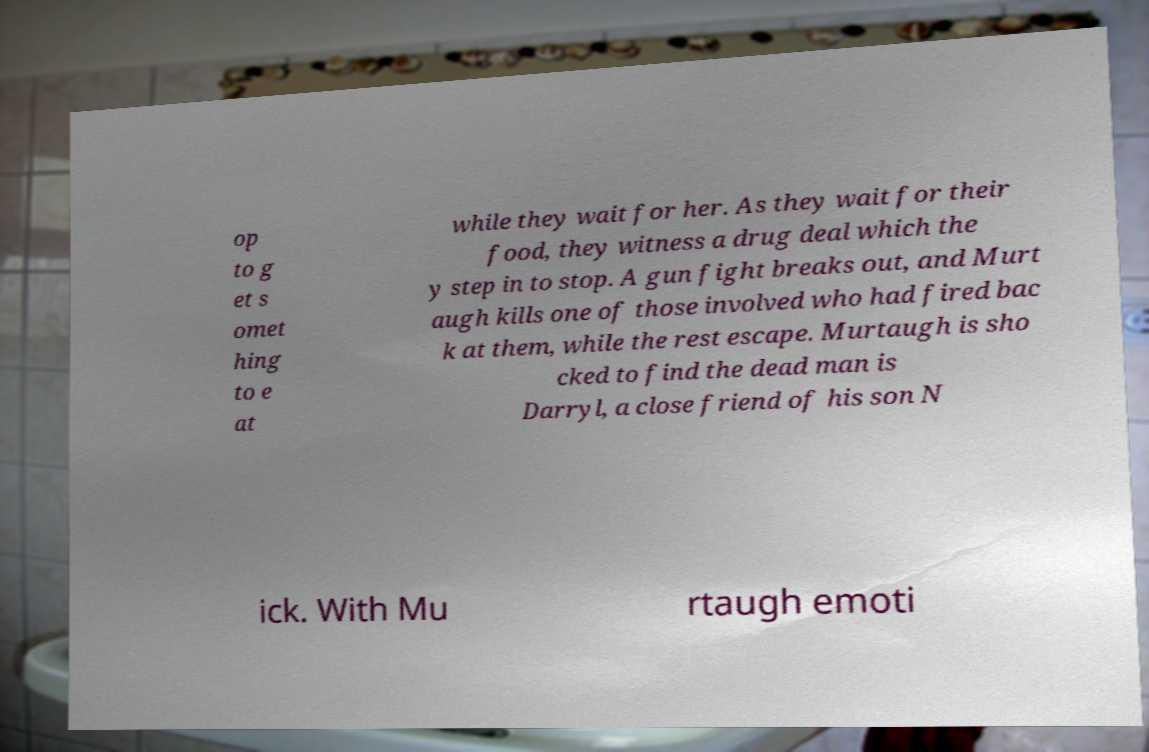What messages or text are displayed in this image? I need them in a readable, typed format. op to g et s omet hing to e at while they wait for her. As they wait for their food, they witness a drug deal which the y step in to stop. A gun fight breaks out, and Murt augh kills one of those involved who had fired bac k at them, while the rest escape. Murtaugh is sho cked to find the dead man is Darryl, a close friend of his son N ick. With Mu rtaugh emoti 